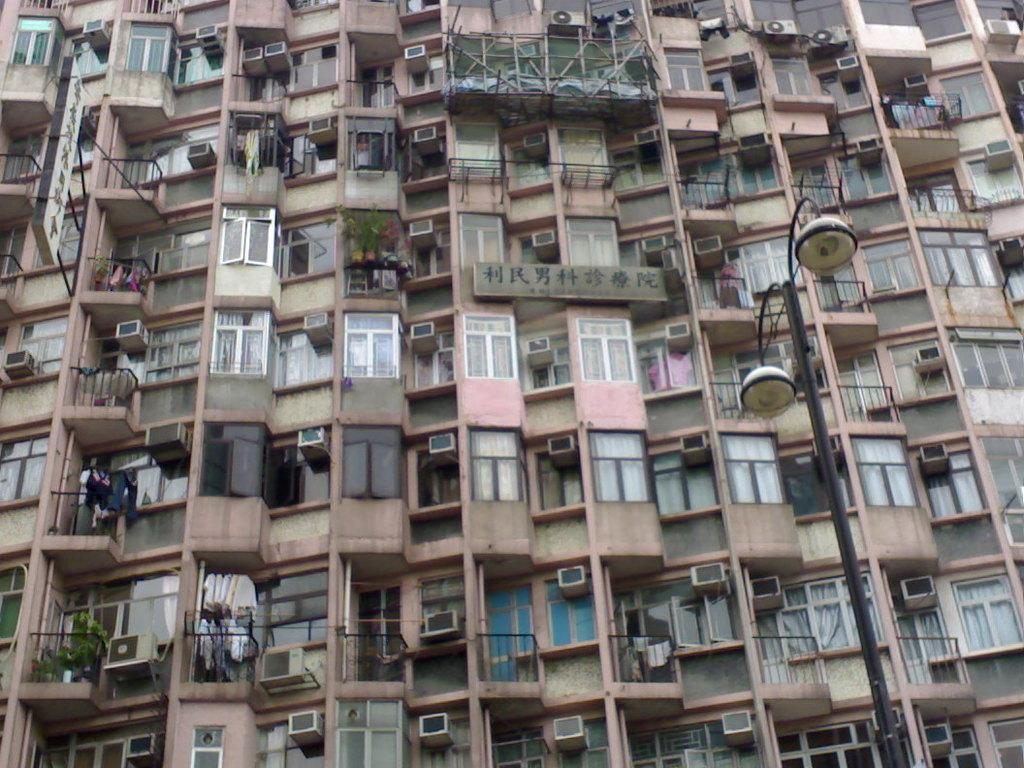What type of structures can be seen in the image? There are buildings in the image. What can be seen illuminating the scene in the image? There are lights in the image. What are the vertical structures supporting the lights and hoardings in the image? There are poles in the image. What type of advertisements or signs are present in the image? There are hoardings in the image. What type of textile items are visible in the image? There are cloths in the image. What type of vegetation is present in the image? There are plants in the image. What type of cooling systems are installed on the buildings in the image? There are air conditioners in the image. What type of light can be seen sparking between the buildings in the image? There is no light sparking between the buildings in the image; the lights are stationary and not producing any sparks. What type of motion can be seen in the image? The image is static, and there is no motion visible. 